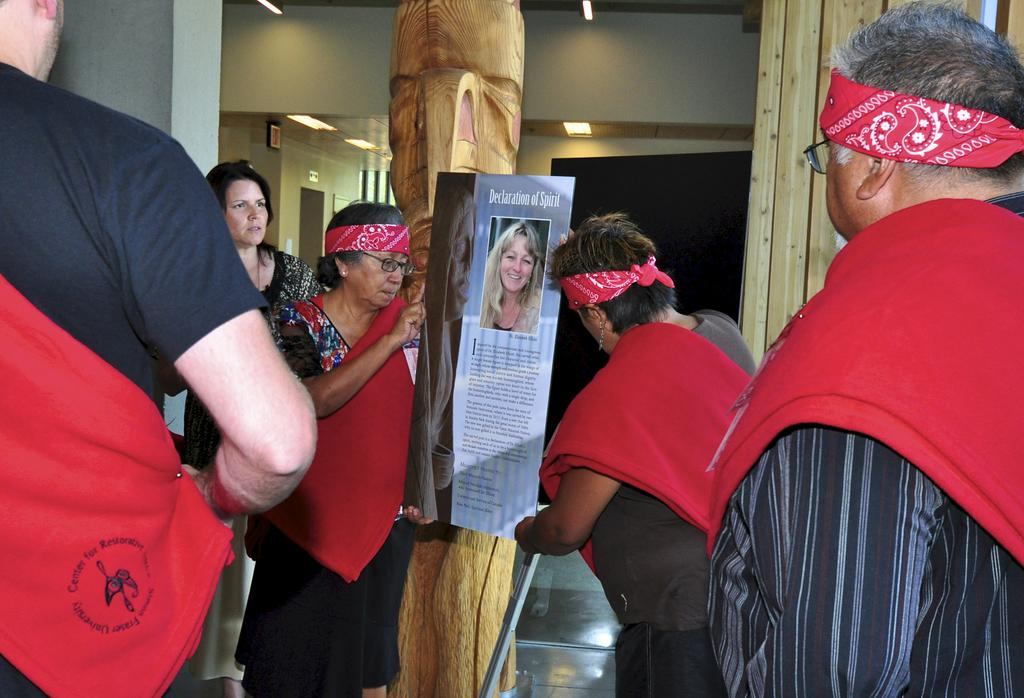How many people are in the image? There is a group of people in the image. What are some of the people holding? Some of the people are holding posters. What can be seen in the middle of the room? There is a pillar in the middle of the room. What sign or rule is being discussed at the meeting in the image? There is no meeting present in the image, so it is not possible to determine what sign or rule might be discussed. 